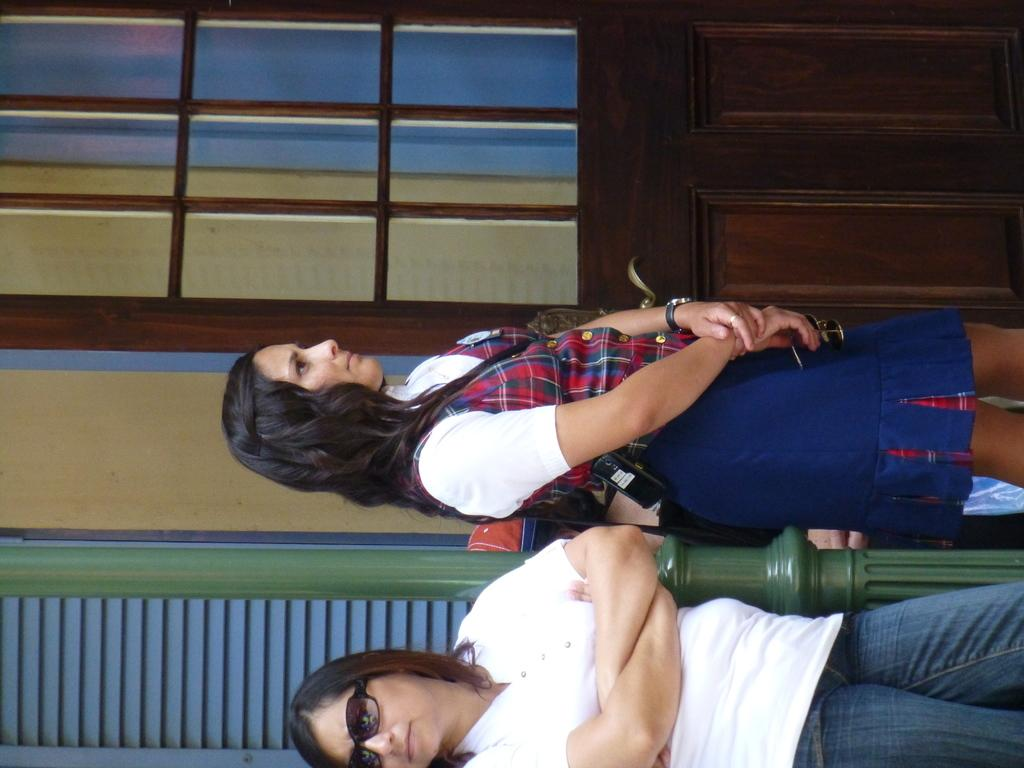How many people are in the image? There are people in the image, but the exact number is not specified. What can be seen on one person's face in the image? One person is wearing spectacles in the image. What is another person holding in the image? Another person is holding spectacles in the image. What can be seen in the background of the image? There is a wall, a pole, and a door in the background of the image. What type of bean is growing in the field behind the people in the image? There is no field or bean present in the image; it features people, spectacles, and background elements such as a wall, a pole, and a door. 